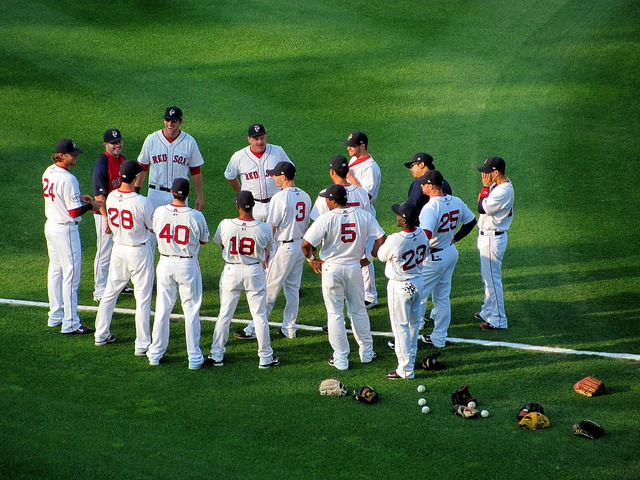Describe the objects in this image and their specific colors. I can see people in darkgreen, white, darkgray, and black tones, people in darkgreen, darkgray, lightgray, and black tones, people in darkgreen, lightgray, and darkgray tones, people in darkgreen, white, darkgray, and black tones, and people in darkgreen, gray, darkgray, and black tones in this image. 